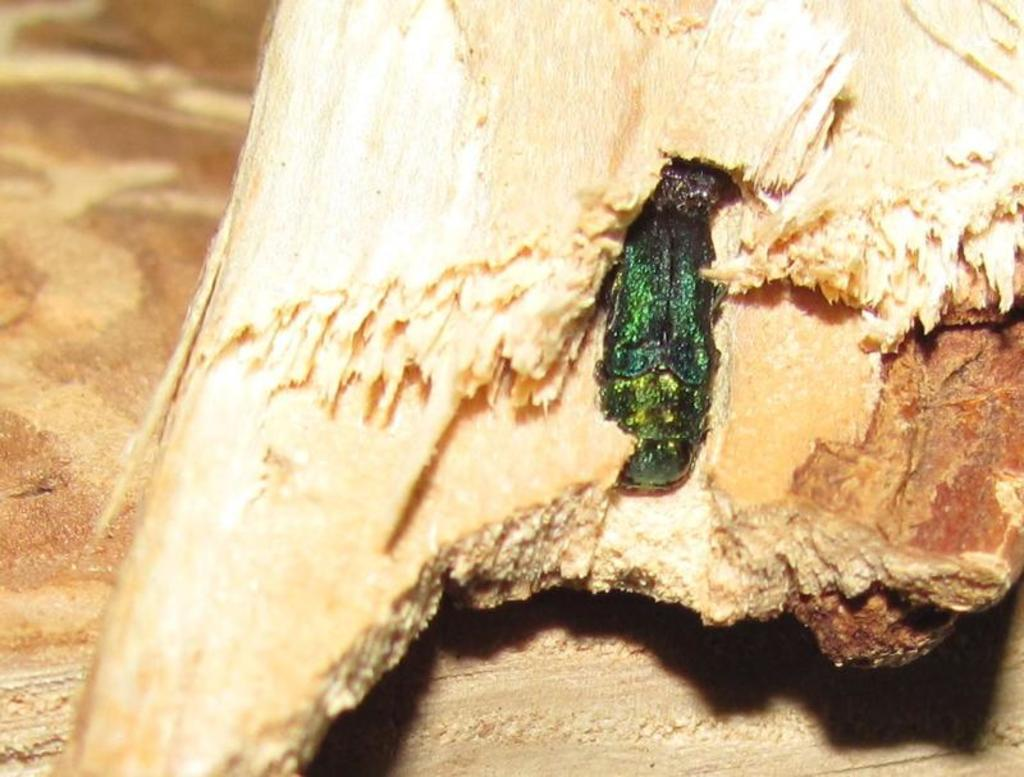What material is present in the image? There is wood in the image. What can be seen in the middle of the image? There appears to be an insect in the middle of the image. What is the reaction of the bear to the insect in the image? There is no bear present in the image, so it is not possible to determine the bear's reaction to the insect. 